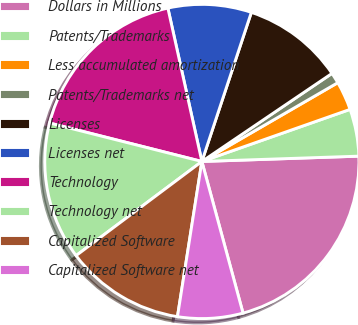<chart> <loc_0><loc_0><loc_500><loc_500><pie_chart><fcel>Dollars in Millions<fcel>Patents/Trademarks<fcel>Less accumulated amortization<fcel>Patents/Trademarks net<fcel>Licenses<fcel>Licenses net<fcel>Technology<fcel>Technology net<fcel>Capitalized Software<fcel>Capitalized Software net<nl><fcel>21.32%<fcel>4.84%<fcel>2.98%<fcel>1.11%<fcel>10.43%<fcel>8.57%<fcel>17.59%<fcel>14.16%<fcel>12.29%<fcel>6.7%<nl></chart> 